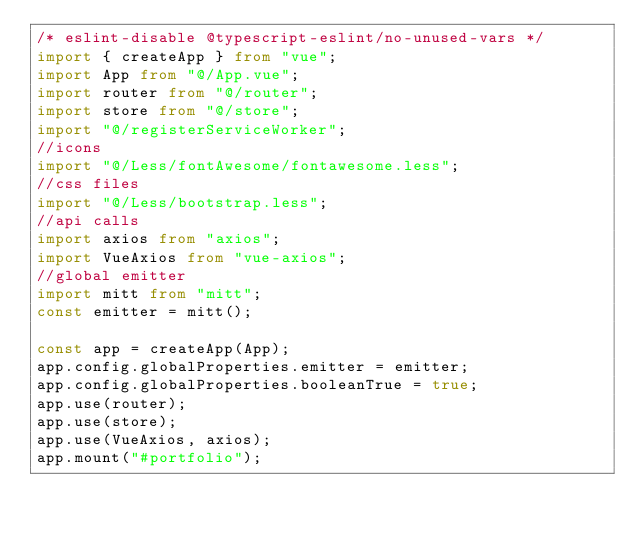<code> <loc_0><loc_0><loc_500><loc_500><_TypeScript_>/* eslint-disable @typescript-eslint/no-unused-vars */
import { createApp } from "vue";
import App from "@/App.vue";
import router from "@/router";
import store from "@/store";
import "@/registerServiceWorker";
//icons
import "@/Less/fontAwesome/fontawesome.less";
//css files
import "@/Less/bootstrap.less";
//api calls
import axios from "axios";
import VueAxios from "vue-axios";
//global emitter
import mitt from "mitt";
const emitter = mitt();

const app = createApp(App);
app.config.globalProperties.emitter = emitter;
app.config.globalProperties.booleanTrue = true;
app.use(router);
app.use(store);
app.use(VueAxios, axios);
app.mount("#portfolio");
</code> 